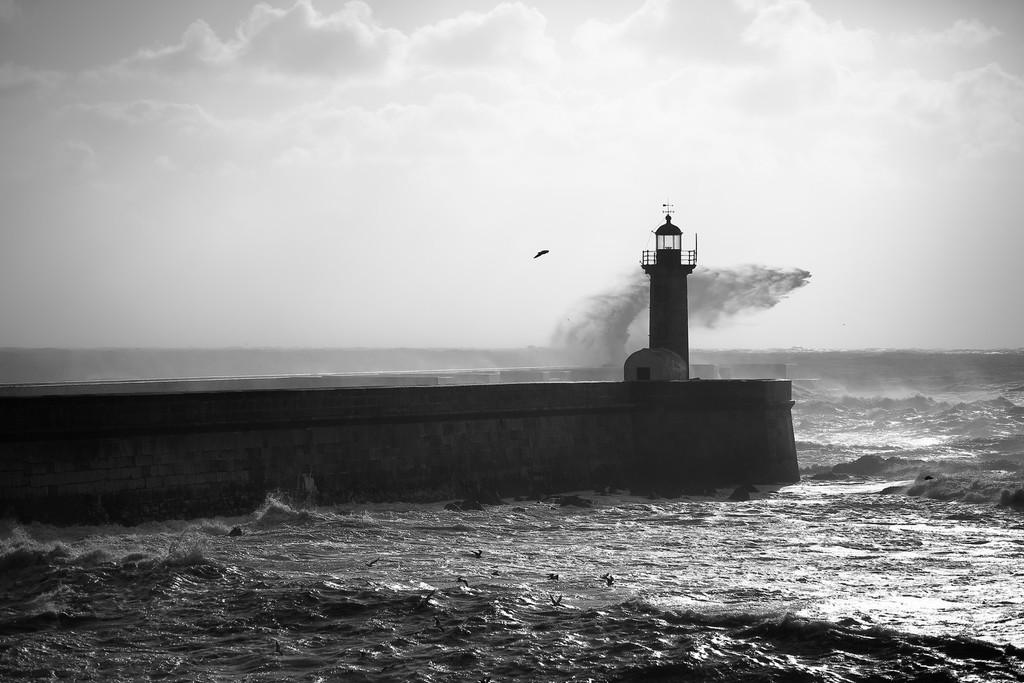What type of structure can be seen in the image? There is a bridge in the image. What other structure is present in the image? There is a lighthouse in the image. What is visible at the top of the image? Clouds are visible at the top of the image. What is present at the bottom of the image? Water is present at the bottom of the image. What type of silk material is being used to play with the lighthouse in the image? There is no silk material or any indication of playing with the lighthouse in the image. 